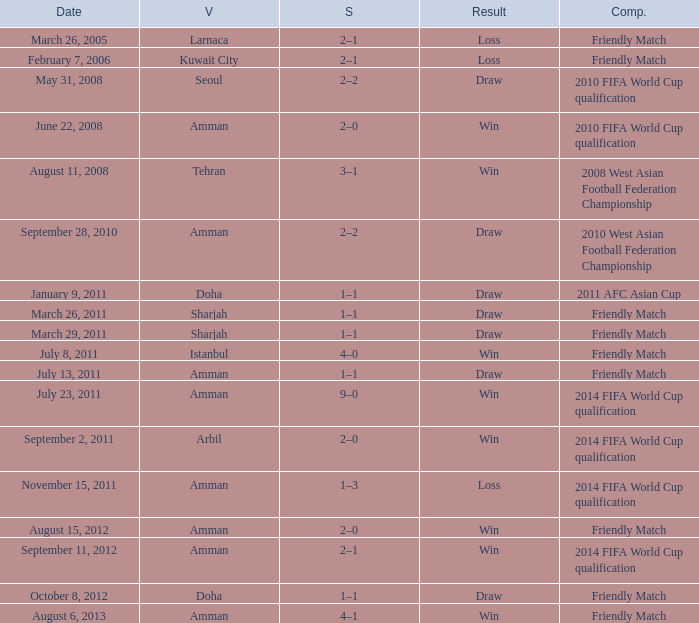I'm looking to parse the entire table for insights. Could you assist me with that? {'header': ['Date', 'V', 'S', 'Result', 'Comp.'], 'rows': [['March 26, 2005', 'Larnaca', '2–1', 'Loss', 'Friendly Match'], ['February 7, 2006', 'Kuwait City', '2–1', 'Loss', 'Friendly Match'], ['May 31, 2008', 'Seoul', '2–2', 'Draw', '2010 FIFA World Cup qualification'], ['June 22, 2008', 'Amman', '2–0', 'Win', '2010 FIFA World Cup qualification'], ['August 11, 2008', 'Tehran', '3–1', 'Win', '2008 West Asian Football Federation Championship'], ['September 28, 2010', 'Amman', '2–2', 'Draw', '2010 West Asian Football Federation Championship'], ['January 9, 2011', 'Doha', '1–1', 'Draw', '2011 AFC Asian Cup'], ['March 26, 2011', 'Sharjah', '1–1', 'Draw', 'Friendly Match'], ['March 29, 2011', 'Sharjah', '1–1', 'Draw', 'Friendly Match'], ['July 8, 2011', 'Istanbul', '4–0', 'Win', 'Friendly Match'], ['July 13, 2011', 'Amman', '1–1', 'Draw', 'Friendly Match'], ['July 23, 2011', 'Amman', '9–0', 'Win', '2014 FIFA World Cup qualification'], ['September 2, 2011', 'Arbil', '2–0', 'Win', '2014 FIFA World Cup qualification'], ['November 15, 2011', 'Amman', '1–3', 'Loss', '2014 FIFA World Cup qualification'], ['August 15, 2012', 'Amman', '2–0', 'Win', 'Friendly Match'], ['September 11, 2012', 'Amman', '2–1', 'Win', '2014 FIFA World Cup qualification'], ['October 8, 2012', 'Doha', '1–1', 'Draw', 'Friendly Match'], ['August 6, 2013', 'Amman', '4–1', 'Win', 'Friendly Match']]} What was the name of the competition that took place on may 31, 2008? 2010 FIFA World Cup qualification. 